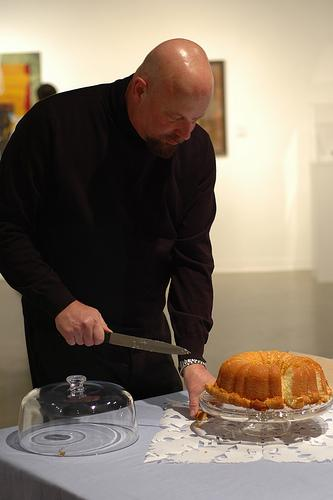Describe the knife the man is using to cut the cake. The knife is a long, silver cake knife with a black handle. What is the man wearing, and what is he doing in the image? The man is wearing all black, including a black long-sleeve shirt and black pants, and he is cutting a cake using a long knife with a black handle. What type of artwork is present in the image? A framed painting with a dark brown frame is hanging on the white wall behind the man. Can you find any objects on the man that indicate the time? Yes, there is a silver watch with a chain band on the man's left wrist. What type of head covering does the man have? The man does not have any head covering; he is bald. Describe the appearance of the cake and the dish it's served on. The cake is a vanilla bundt cake without frosting, served on a glass cake plate with a glass cover and a white doily beneath the dish. How many objects are involved in the cake-serving setup (including the cake itself)? The cake-serving setup consists of six objects: the cake, glass cake plate, glass lid, white doily, table with tablecloth, and the cake knife. What sentiment does the image convey? The image conveys a neutral, everyday sentiment as a man is simply captured in the moment of cutting a cake. Is there any evidence of the man's handedness in the image? Yes, the man appears to be right-handed as he is holding the knife in his right hand. What is the color of the tablecloth and what type of material does it seem to be? The tablecloth is white and appears to be made of a cloth material. Did you notice the cat sitting under the table, waiting for a bite of the cake? No wonder it's so quiet here; the cat must be hiding! Make sure to pay attention to the woman in the yellow dress standing next to the man. Her dress creates a beautiful contrast to the man's black attire. Can you find the red roses in the decorative centerpiece at the center of the table? The roses add a romantic touch to the environment. Where is the plate of cookies next to the cake? Those cookies look delicious alongside the cake. On the other side of the table, you should be able to find a red umbrella. It seems like someone forgot their umbrella there. Can you point out the blue vase next to the cake? The vase adds a touch of elegance to the table setting. 